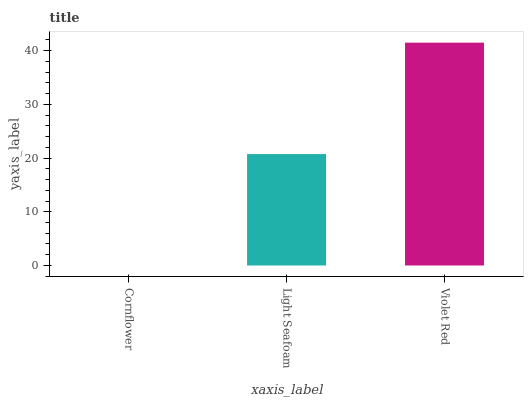Is Cornflower the minimum?
Answer yes or no. Yes. Is Violet Red the maximum?
Answer yes or no. Yes. Is Light Seafoam the minimum?
Answer yes or no. No. Is Light Seafoam the maximum?
Answer yes or no. No. Is Light Seafoam greater than Cornflower?
Answer yes or no. Yes. Is Cornflower less than Light Seafoam?
Answer yes or no. Yes. Is Cornflower greater than Light Seafoam?
Answer yes or no. No. Is Light Seafoam less than Cornflower?
Answer yes or no. No. Is Light Seafoam the high median?
Answer yes or no. Yes. Is Light Seafoam the low median?
Answer yes or no. Yes. Is Cornflower the high median?
Answer yes or no. No. Is Violet Red the low median?
Answer yes or no. No. 